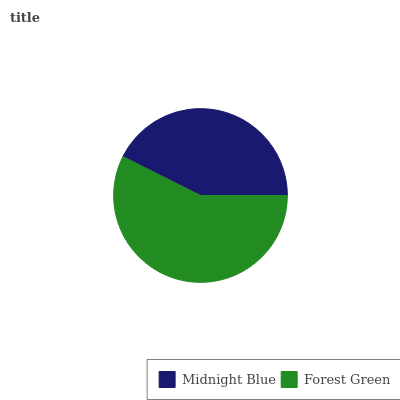Is Midnight Blue the minimum?
Answer yes or no. Yes. Is Forest Green the maximum?
Answer yes or no. Yes. Is Forest Green the minimum?
Answer yes or no. No. Is Forest Green greater than Midnight Blue?
Answer yes or no. Yes. Is Midnight Blue less than Forest Green?
Answer yes or no. Yes. Is Midnight Blue greater than Forest Green?
Answer yes or no. No. Is Forest Green less than Midnight Blue?
Answer yes or no. No. Is Forest Green the high median?
Answer yes or no. Yes. Is Midnight Blue the low median?
Answer yes or no. Yes. Is Midnight Blue the high median?
Answer yes or no. No. Is Forest Green the low median?
Answer yes or no. No. 